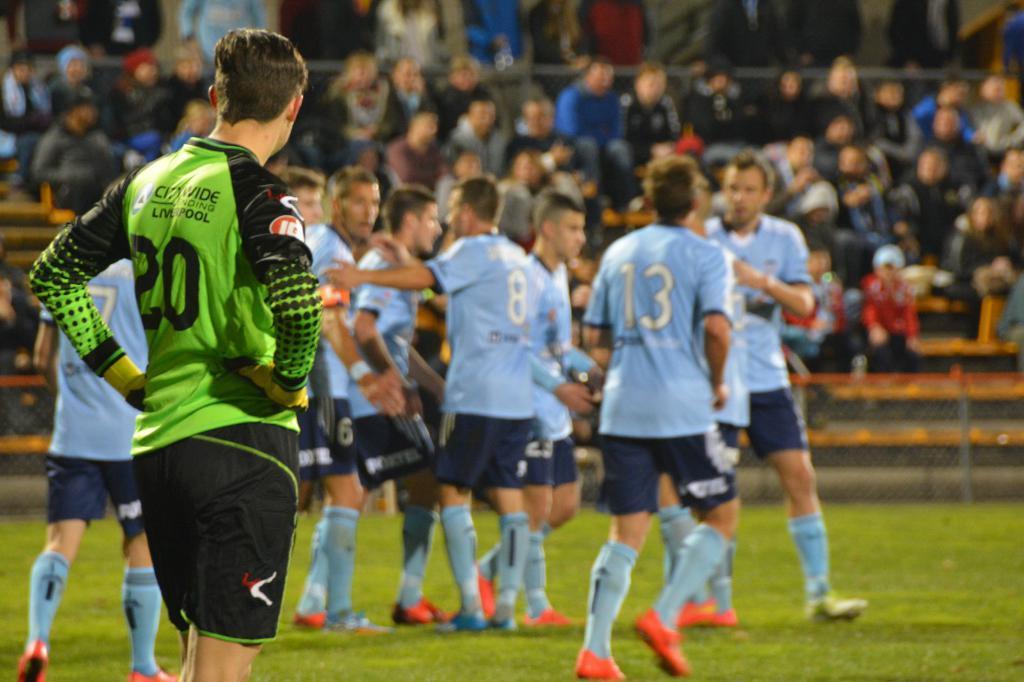Describe this image in one or two sentences. In the foreground of the image there is a person wearing green color sports dress standing, there are some group of persons wearing blue color sports dress standing on ground and in the background of the image there is fencing and there are some persons sitting on chairs. 